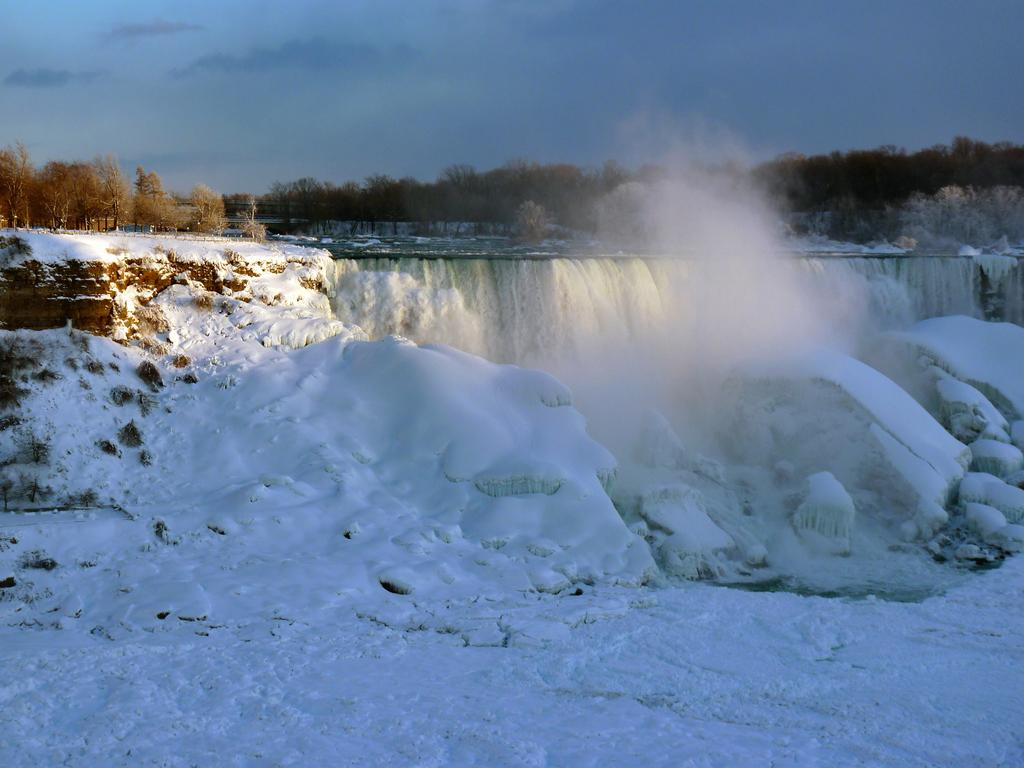What type of weather condition is depicted in the image? There is snow in the image. What natural elements can be seen in the image? There are trees in the image. What is visible in the background of the image? The sky is visible in the background of the image. How many letters are visible on the basin in the image? There is no basin present in the image, and therefore no letters can be observed on it. 